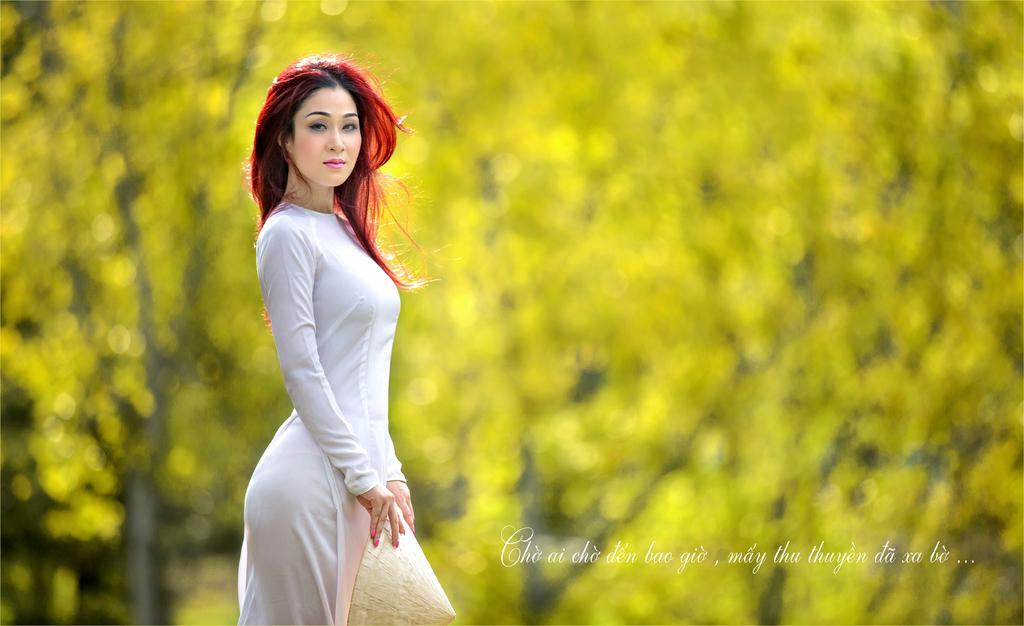What is the main subject of the image? The main subject of the image is a woman. What is the woman wearing in the image? The woman is wearing a white dress in the image. What is the woman doing in the image? The woman is standing in the image. What can be seen in the background of the image? There are trees in the background of the image. Can you tell me how many porters are assisting the woman in the image? There are no porters present in the image; it only features a woman standing in a white dress with trees in the background. What scientific theory is being demonstrated by the woman in the image? There is no scientific theory being demonstrated by the woman in the image. 